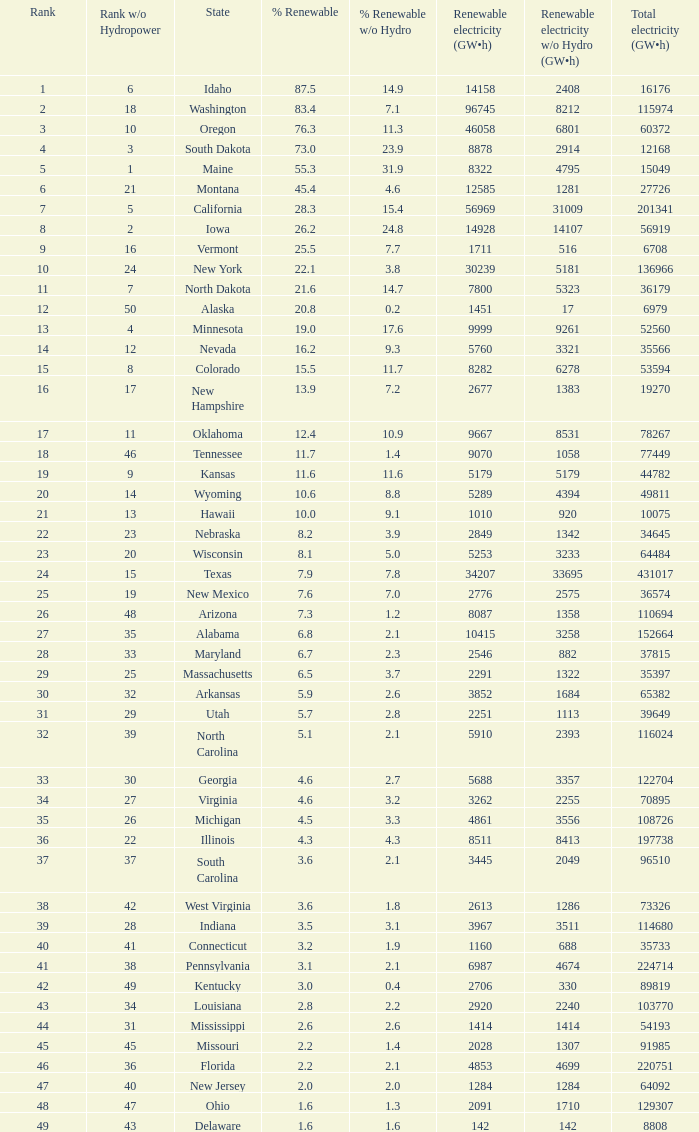Which states have renewable electricity equal to 9667 (gw×h)? Oklahoma. 